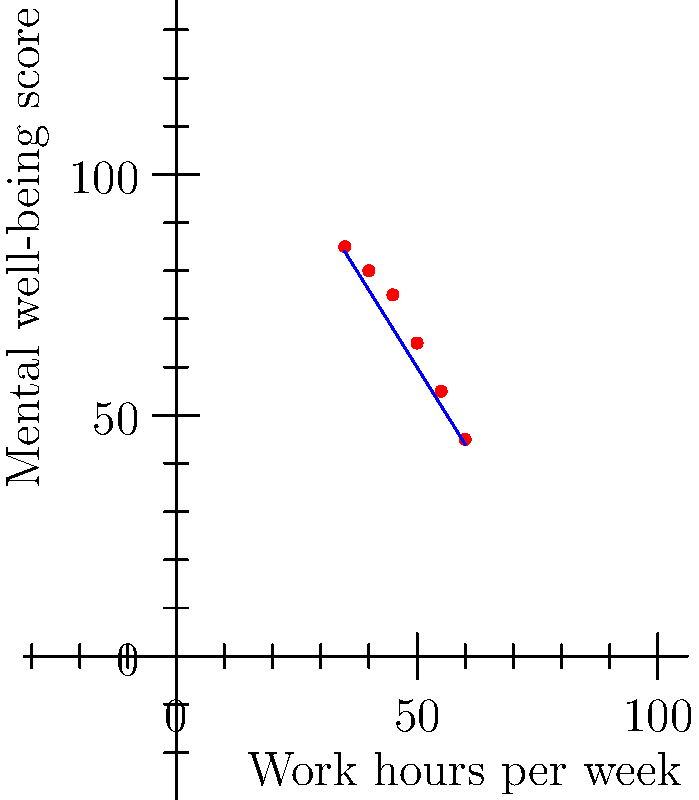Анализируя график зависимости оценки психического благополучия от количества рабочих часов в неделю, какую тенденцию вы можете определить, и как это может повлиять на рекомендации по балансу между работой и личной жизнью? Для анализа графика и определения тенденции следуем следующим шагам:

1. Рассмотрим расположение точек на графике:
   - По оси X отложены рабочие часы в неделю (от 35 до 60).
   - По оси Y отложены оценки психического благополучия (от 45 до 85).

2. Наблюдаем общую тенденцию:
   - С увеличением рабочих часов оценки психического благополучия снижаются.

3. Анализируем линию тренда:
   - Синяя линия на графике показывает отрицательную линейную зависимость.
   - Уравнение линии тренда примерно $y = -1.6x + 140$, где $x$ - рабочие часы, $y$ - оценка благополучия.

4. Интерпретируем результаты:
   - Каждый дополнительный час работы в неделю связан со снижением оценки благополучия примерно на 1.6 пункта.
   - При 35 часах работы в неделю оценка благополучия около 85.
   - При 60 часах работы в неделю оценка благополучия падает до 45.

5. Формулируем рекомендации:
   - Для поддержания высокого уровня психического благополучия следует ограничивать количество рабочих часов.
   - Оптимальный баланс, судя по графику, достигается при 35-40 рабочих часах в неделю.

Таким образом, наблюдается четкая отрицательная корреляция между количеством рабочих часов и психическим благополучием, что указывает на необходимость поддержания баланса между работой и личной жизнью.
Answer: Отрицательная корреляция; ограничить рабочие часы до 35-40 в неделю для оптимального благополучия. 